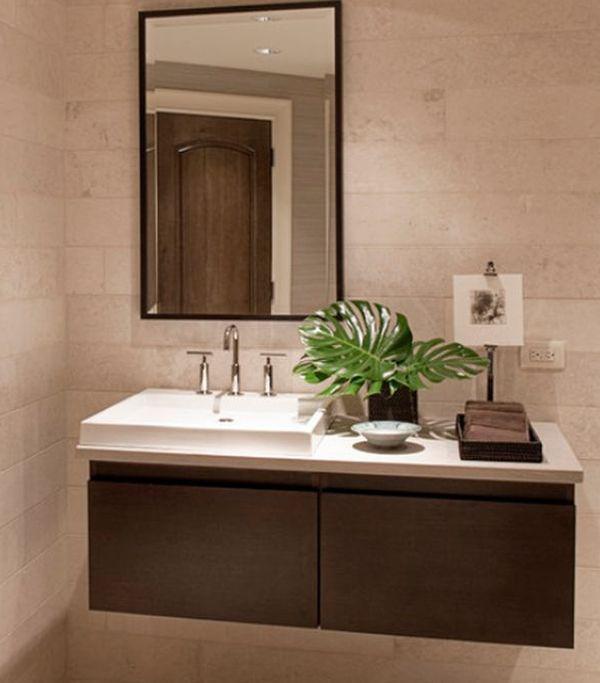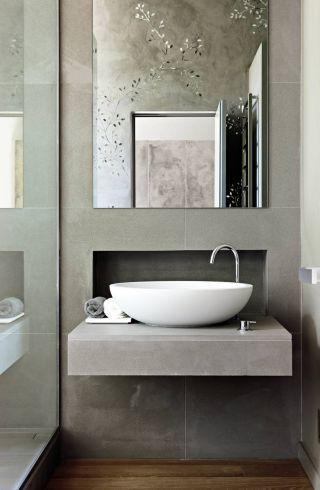The first image is the image on the left, the second image is the image on the right. For the images displayed, is the sentence "An image includes a round white vessel sink." factually correct? Answer yes or no. Yes. The first image is the image on the left, the second image is the image on the right. For the images shown, is this caption "The right image features at least one round white bowl-shaped sink atop a vanity." true? Answer yes or no. Yes. The first image is the image on the left, the second image is the image on the right. Given the left and right images, does the statement "Vanities in both images have an equal number of sinks." hold true? Answer yes or no. Yes. 